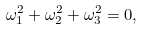Convert formula to latex. <formula><loc_0><loc_0><loc_500><loc_500>\omega _ { 1 } ^ { 2 } + \omega _ { 2 } ^ { 2 } + \omega _ { 3 } ^ { 2 } = 0 ,</formula> 